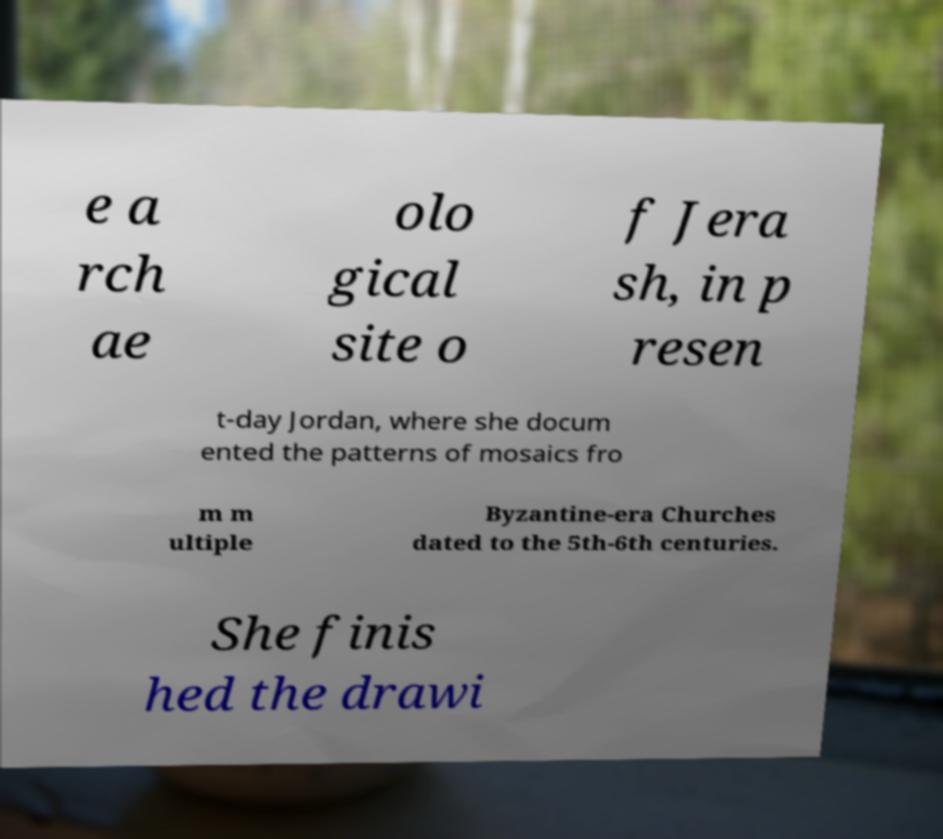Can you accurately transcribe the text from the provided image for me? e a rch ae olo gical site o f Jera sh, in p resen t-day Jordan, where she docum ented the patterns of mosaics fro m m ultiple Byzantine-era Churches dated to the 5th-6th centuries. She finis hed the drawi 